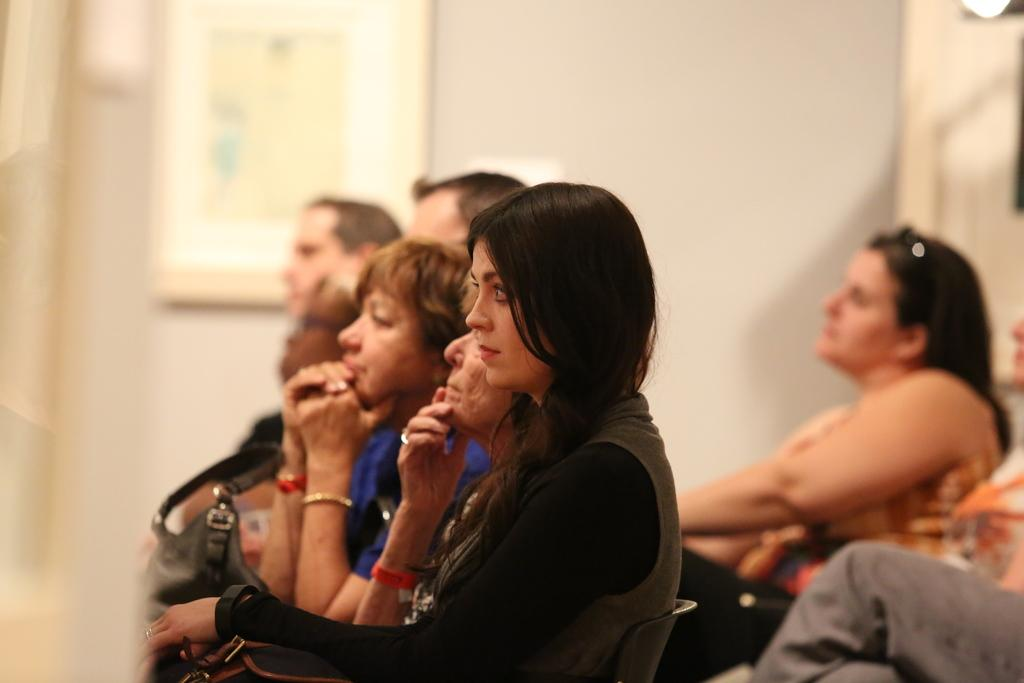What are the people in the image doing? There is a group of people sitting in the image. What object can be seen near the people? There is a handbag in the image. What can be seen in the background of the image? There is a frame attached to the wall in the background of the image. What type of berry is being used as a prop by the creature in the image? There is no berry or creature present in the image. How does the plane in the image affect the group of people sitting? There is no plane present in the image; it only features a group of people sitting and a handbag. 